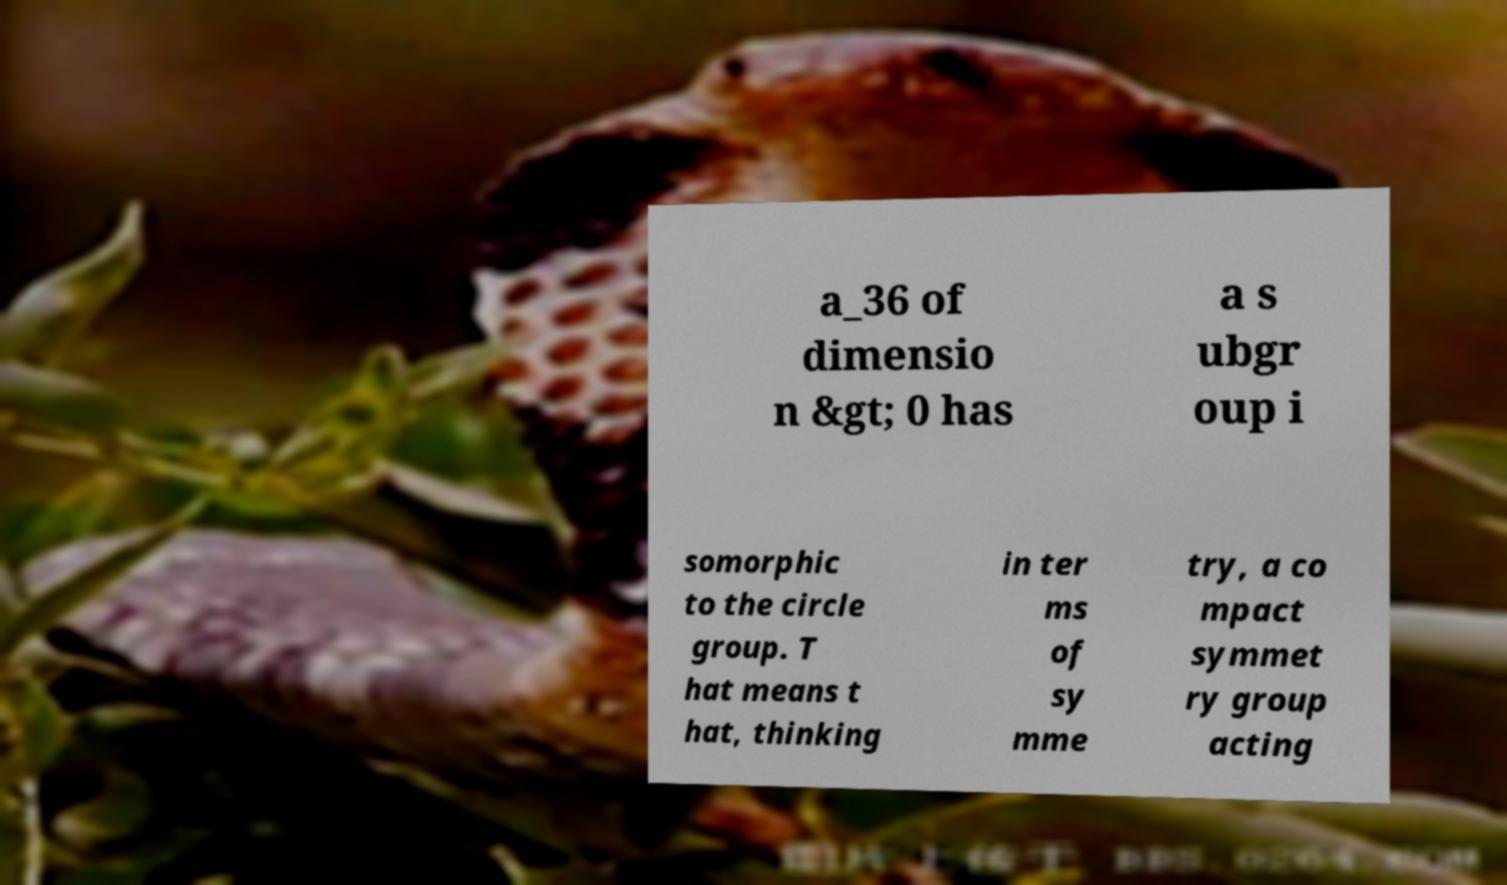I need the written content from this picture converted into text. Can you do that? a_36 of dimensio n &gt; 0 has a s ubgr oup i somorphic to the circle group. T hat means t hat, thinking in ter ms of sy mme try, a co mpact symmet ry group acting 